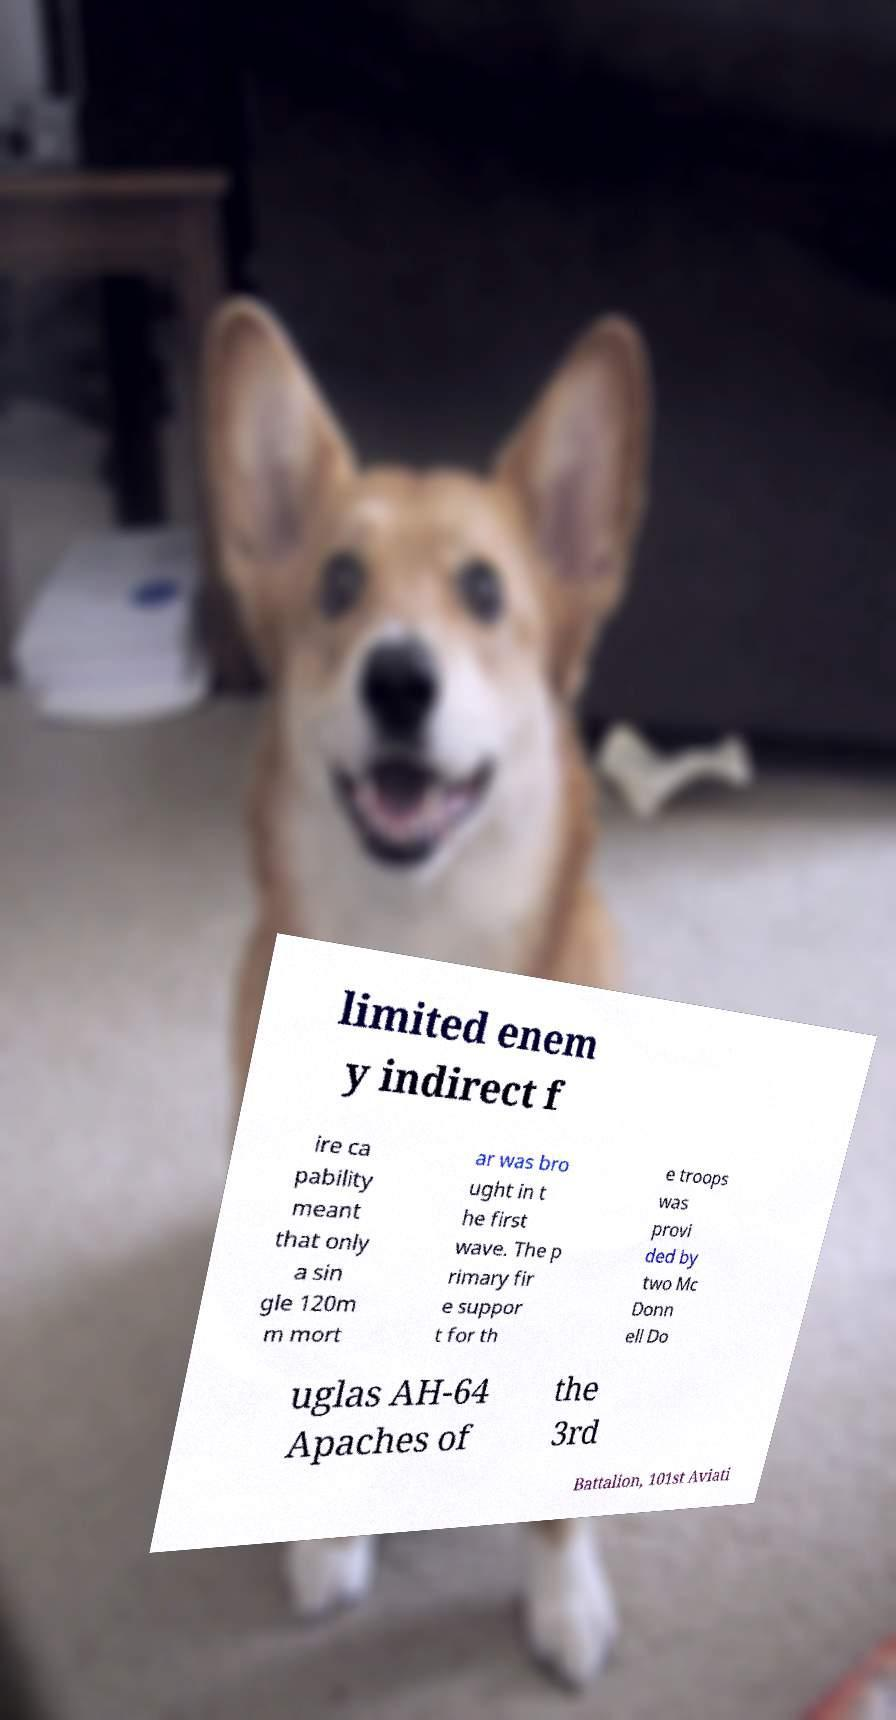For documentation purposes, I need the text within this image transcribed. Could you provide that? limited enem y indirect f ire ca pability meant that only a sin gle 120m m mort ar was bro ught in t he first wave. The p rimary fir e suppor t for th e troops was provi ded by two Mc Donn ell Do uglas AH-64 Apaches of the 3rd Battalion, 101st Aviati 